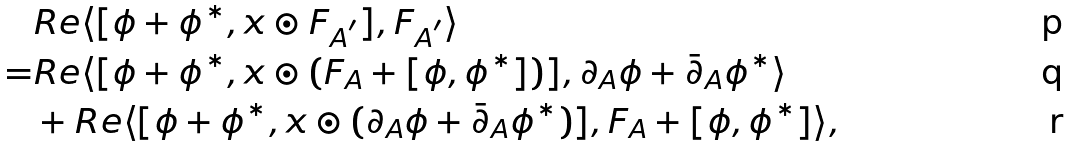Convert formula to latex. <formula><loc_0><loc_0><loc_500><loc_500>& R e \langle [ \phi + \phi ^ { * } , x \odot F _ { A ^ { ^ { \prime } } } ] , F _ { A ^ { ^ { \prime } } } \rangle \\ = & R e \langle [ \phi + \phi ^ { * } , x \odot ( F _ { A } + [ \phi , \phi ^ { * } ] ) ] , \partial _ { A } \phi + \bar { \partial } _ { A } \phi ^ { * } \rangle \\ & + R e \langle [ \phi + \phi ^ { * } , x \odot ( \partial _ { A } \phi + \bar { \partial } _ { A } \phi ^ { * } ) ] , F _ { A } + [ \phi , \phi ^ { * } ] \rangle ,</formula> 